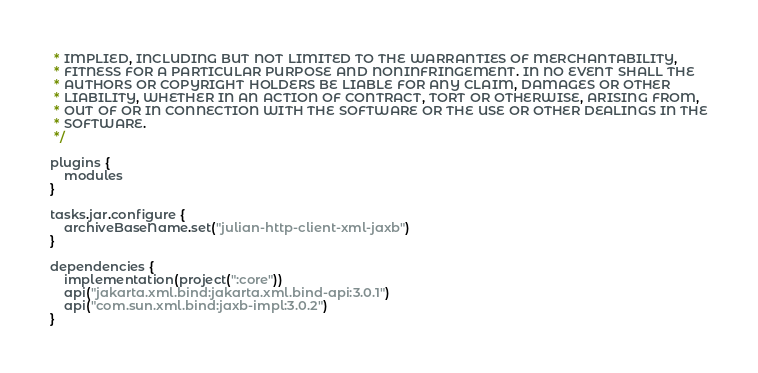<code> <loc_0><loc_0><loc_500><loc_500><_Kotlin_> * IMPLIED, INCLUDING BUT NOT LIMITED TO THE WARRANTIES OF MERCHANTABILITY,
 * FITNESS FOR A PARTICULAR PURPOSE AND NONINFRINGEMENT. IN NO EVENT SHALL THE
 * AUTHORS OR COPYRIGHT HOLDERS BE LIABLE FOR ANY CLAIM, DAMAGES OR OTHER
 * LIABILITY, WHETHER IN AN ACTION OF CONTRACT, TORT OR OTHERWISE, ARISING FROM,
 * OUT OF OR IN CONNECTION WITH THE SOFTWARE OR THE USE OR OTHER DEALINGS IN THE
 * SOFTWARE.
 */

plugins {
    modules
}

tasks.jar.configure {
    archiveBaseName.set("julian-http-client-xml-jaxb")
}

dependencies {
    implementation(project(":core"))
    api("jakarta.xml.bind:jakarta.xml.bind-api:3.0.1")
    api("com.sun.xml.bind:jaxb-impl:3.0.2")
}</code> 